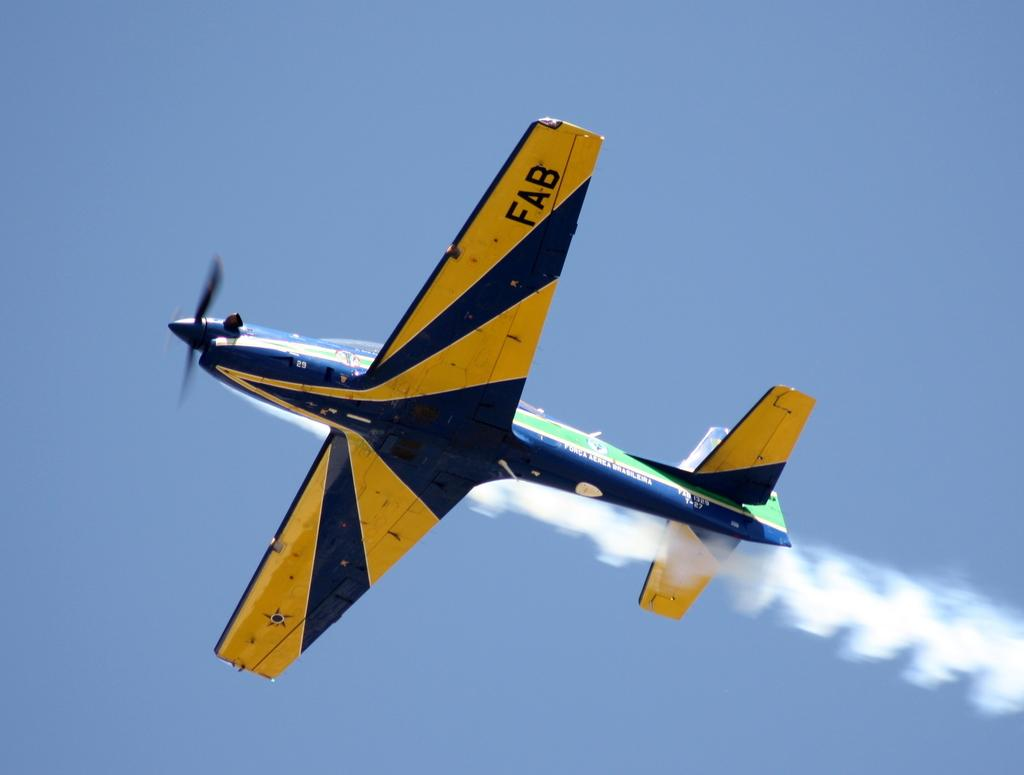What is the main subject of the picture? The main subject of the picture is an aircraft. What is the aircraft doing in the picture? The aircraft is flying in the sky. What type of disgust can be seen on the clover in the image? There is no clover or disgust present in the image; it features an aircraft flying in the sky. What type of exchange is happening between the aircraft and the ground in the image? There is no exchange between the aircraft and the ground depicted in the image; the aircraft is simply flying in the sky. 